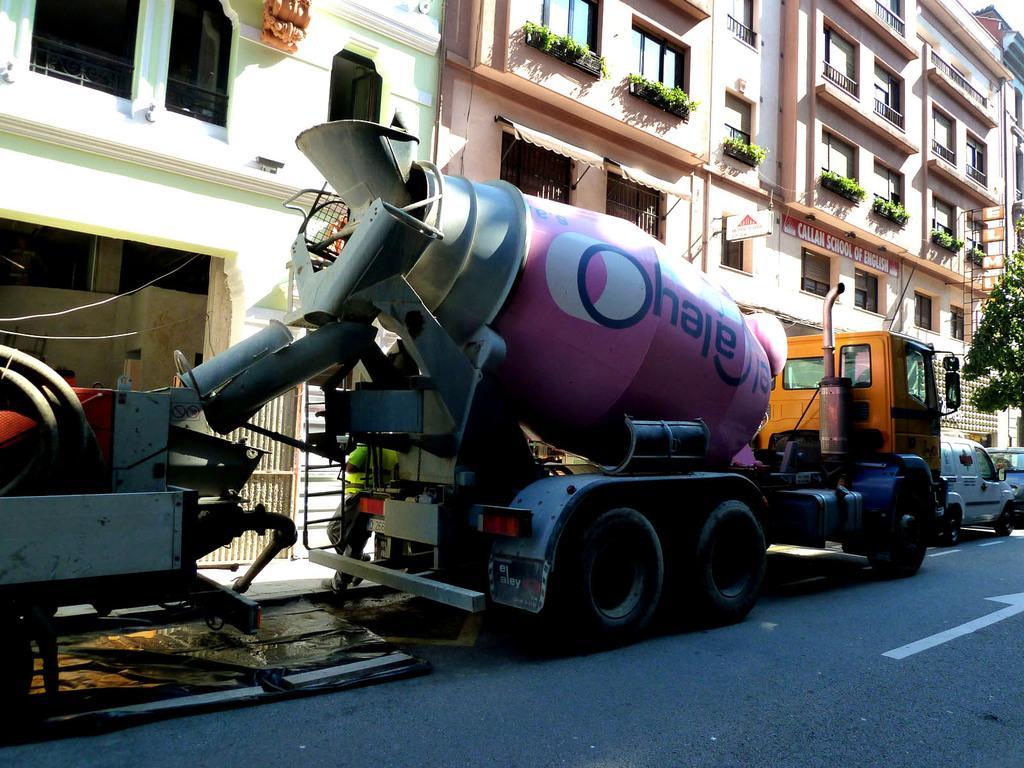In one or two sentences, can you explain what this image depicts? In the image there is a truck and in front of the truck there are two other vehicles. Behind the vehicles there's a huge building and on the right side there is a tree. 